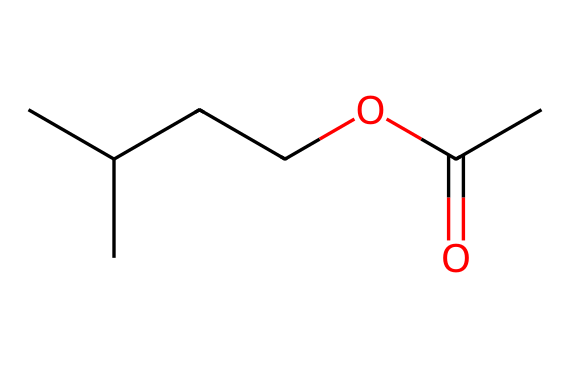What is the total number of carbon atoms in isoamyl acetate? In the SMILES representation CC(C)CCOC(C)=O, the 'C' letters represent carbon atoms. There are five 'C's before the ester functional group and one 'C' in the ester, making a total of six carbon atoms.
Answer: six How many oxygen atoms are in isoamyl acetate? In the SMILES representation, the 'O' letters indicate oxygen atoms. There are two 'O's present in the compound: one in the ester group and one as part of the carbonyl group.
Answer: two What type of functional group is present in isoamyl acetate? The presence of the 'C(=O)' and 'O' connected to the carbon chain indicates that the compound contains an ester functional group.
Answer: ester Does isoamyl acetate have a branched or straight-chain alkyl group? The presence of 'CC(C)' indicates that there is a branch on the carbon chain, showing that it is a branched alkyl group rather than a straight-chain.
Answer: branched What type of compound is isoamyl acetate primarily used as in the food industry? isoamyl acetate is used as a flavoring agent in the food industry, particularly for its banana-like scent.
Answer: flavoring agent In terms of polarity, would isoamyl acetate be classified as polar or non-polar? Esters like isoamyl acetate typically have a non-polar alkyl chain, leading to an overall non-polar character despite the presence of oxygen; thus it is non-polar.
Answer: non-polar 